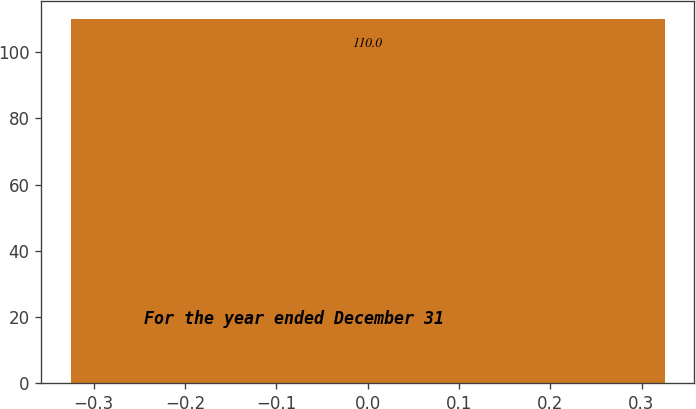<chart> <loc_0><loc_0><loc_500><loc_500><bar_chart><fcel>For the year ended December 31<nl><fcel>110<nl></chart> 